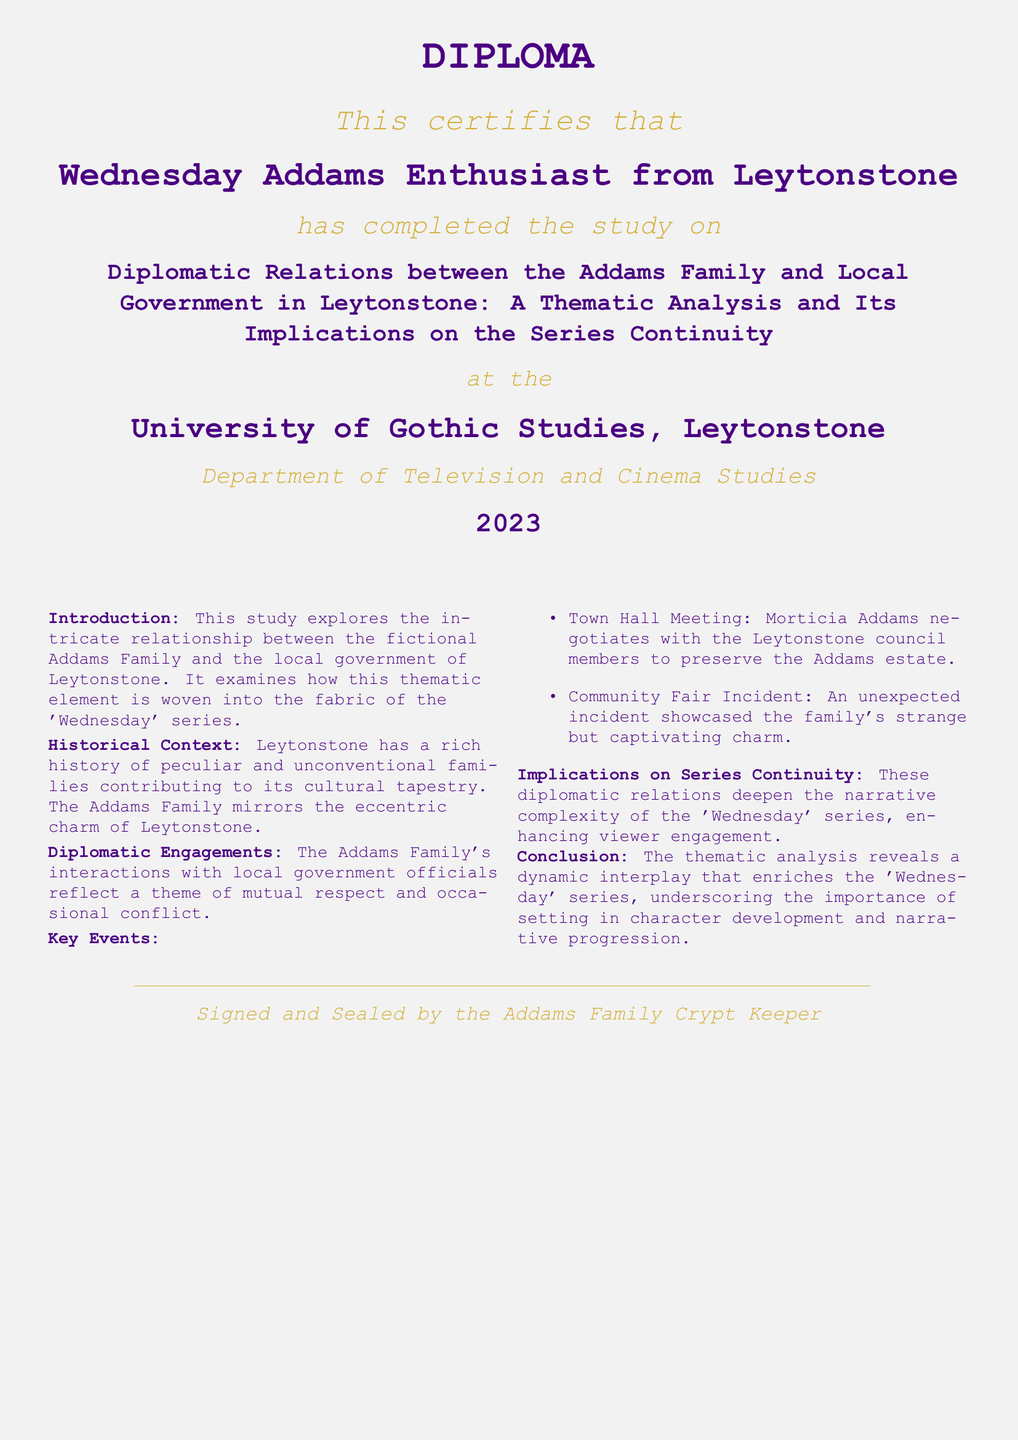What is the title of the study? The title of the study is presented prominently on the diploma, summarizing the research focus.
Answer: Diplomatic Relations between the Addams Family and Local Government in Leytonstone: A Thematic Analysis and Its Implications on the Series Continuity Who is the diploma issued to? The recipient of the diploma is indicated directly under the title, showcasing their identity as a fan.
Answer: Wednesday Addams Enthusiast from Leytonstone What year was the diploma awarded? The year of certification is located towards the bottom of the diploma, indicating when the study was completed.
Answer: 2023 What is the name of the university? The university is mentioned on the diploma, presenting the institution where the study was conducted.
Answer: University of Gothic Studies, Leytonstone What type of document is this? This document is specifically formatted and recognized as providing educational certification.
Answer: Diploma What key event involved Morticia Addams? A significant event is highlighted, showcasing interaction with local governance.
Answer: Town Hall Meeting What theme is explored in the study? The thematic focus of the study is reflected in the title and introduction of the diploma.
Answer: Diplomatic relations How does the study characterize Leytonstone? The introduction and historical context sections provide insight into how the locale is perceived.
Answer: Peculiar and unconventional families What department is associated with the diploma? The department associated with this study is clearly stated on the diploma.
Answer: Department of Television and Cinema Studies 